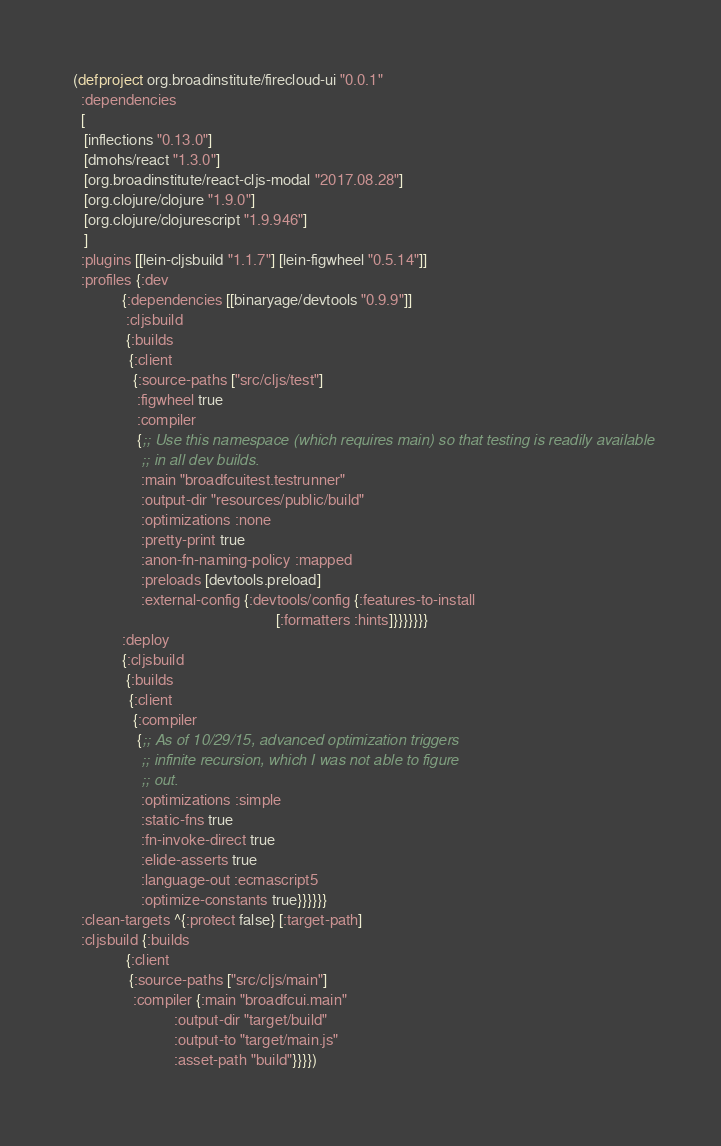Convert code to text. <code><loc_0><loc_0><loc_500><loc_500><_Clojure_>(defproject org.broadinstitute/firecloud-ui "0.0.1"
  :dependencies
  [
   [inflections "0.13.0"]
   [dmohs/react "1.3.0"]
   [org.broadinstitute/react-cljs-modal "2017.08.28"]
   [org.clojure/clojure "1.9.0"]
   [org.clojure/clojurescript "1.9.946"]
   ]
  :plugins [[lein-cljsbuild "1.1.7"] [lein-figwheel "0.5.14"]]
  :profiles {:dev
             {:dependencies [[binaryage/devtools "0.9.9"]]
              :cljsbuild
              {:builds
               {:client
                {:source-paths ["src/cljs/test"]
                 :figwheel true
                 :compiler
                 {;; Use this namespace (which requires main) so that testing is readily available
                  ;; in all dev builds.
                  :main "broadfcuitest.testrunner"
                  :output-dir "resources/public/build"
                  :optimizations :none
                  :pretty-print true
                  :anon-fn-naming-policy :mapped
                  :preloads [devtools.preload]
                  :external-config {:devtools/config {:features-to-install
                                                      [:formatters :hints]}}}}}}}
             :deploy
             {:cljsbuild
              {:builds
               {:client
                {:compiler
                 {;; As of 10/29/15, advanced optimization triggers
                  ;; infinite recursion, which I was not able to figure
                  ;; out.
                  :optimizations :simple
                  :static-fns true
                  :fn-invoke-direct true
                  :elide-asserts true
                  :language-out :ecmascript5
                  :optimize-constants true}}}}}}
  :clean-targets ^{:protect false} [:target-path]
  :cljsbuild {:builds
              {:client
               {:source-paths ["src/cljs/main"]
                :compiler {:main "broadfcui.main"
                           :output-dir "target/build"
                           :output-to "target/main.js"
                           :asset-path "build"}}}})
</code> 